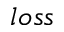Convert formula to latex. <formula><loc_0><loc_0><loc_500><loc_500>l o s s</formula> 